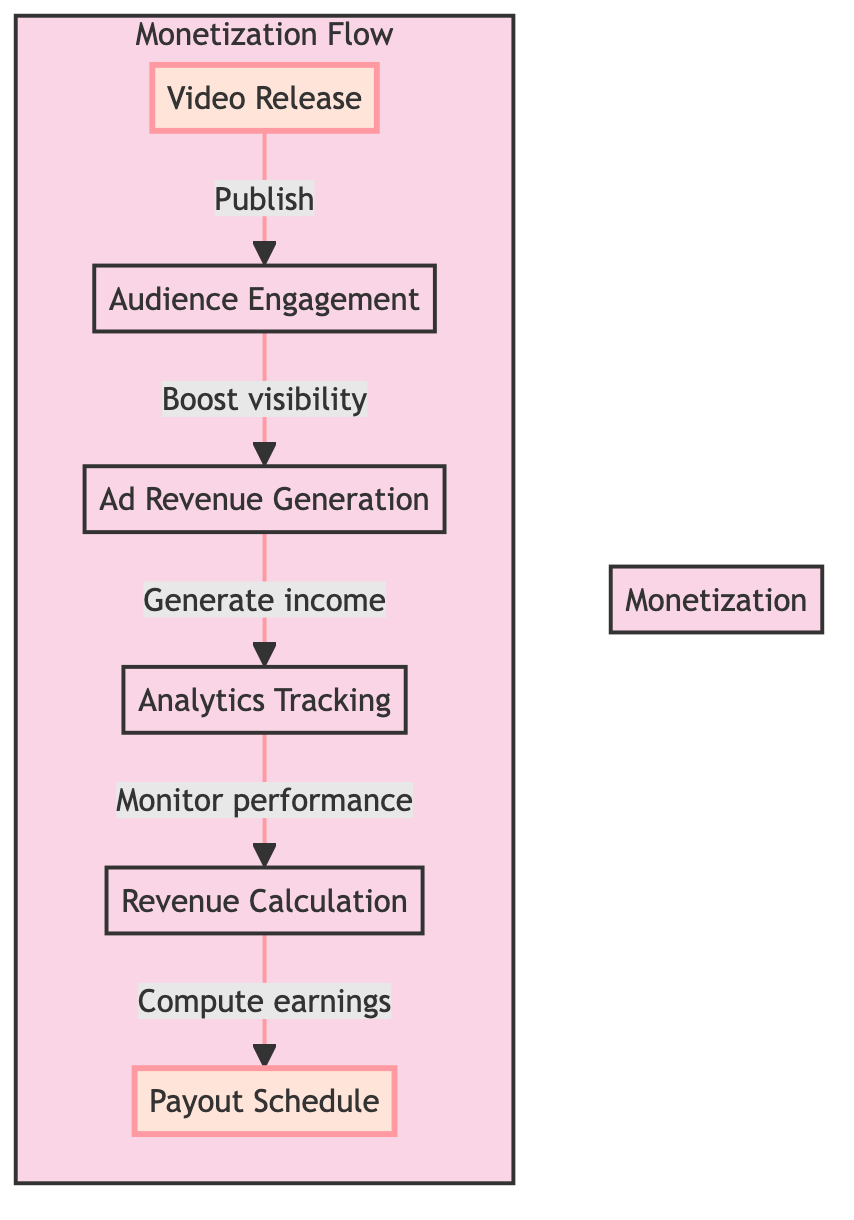What is the first step in the monetization flow? The first step in the monetization flow is "Video Release," which is where the video is published on YouTube after editing and final review.
Answer: Video Release How many nodes are there in the monetization flow? The monetization flow contains six nodes: Video Release, Audience Engagement, Ad Revenue Generation, Analytics Tracking, Revenue Calculation, and Payout Schedule.
Answer: Six What is the last step in the monetization flow? The last step in the monetization flow is "Payout Schedule," which is when the content creator receives payment from YouTube.
Answer: Payout Schedule Which node generates revenue based on views and clicks? The node that generates revenue based on views and clicks is "Ad Revenue Generation," where YouTube runs ads on the video.
Answer: Ad Revenue Generation What does the "Analytics Tracking" node involve? The "Analytics Tracking" node involves monitoring video performance metrics using YouTube Analytics. This tracking helps the creator understand how well their video is performing.
Answer: Monitor performance What is the relationship between "Audience Engagement" and "Ad Revenue Generation"? The relationship between "Audience Engagement" and "Ad Revenue Generation" is that audience engagement, through liking, commenting, and sharing, boosts the video's visibility, which is crucial for generating ad revenue.
Answer: Boost visibility How do creators calculate their revenue in the flow? Creators calculate their revenue in the flow during the "Revenue Calculation" step, where they compute their earnings based on ad performance and viewer engagement metrics.
Answer: Compute earnings What flows into the "Analytics Tracking" node? The "Analytics Tracking" node flows from "Ad Revenue Generation," indicating that revenue generation leads to monitoring video performance.
Answer: Ad Revenue Generation Which node has a direct link to "Payout Schedule"? The node that has a direct link to "Payout Schedule" is "Revenue Calculation," as it computes earnings that lead to payment.
Answer: Revenue Calculation 